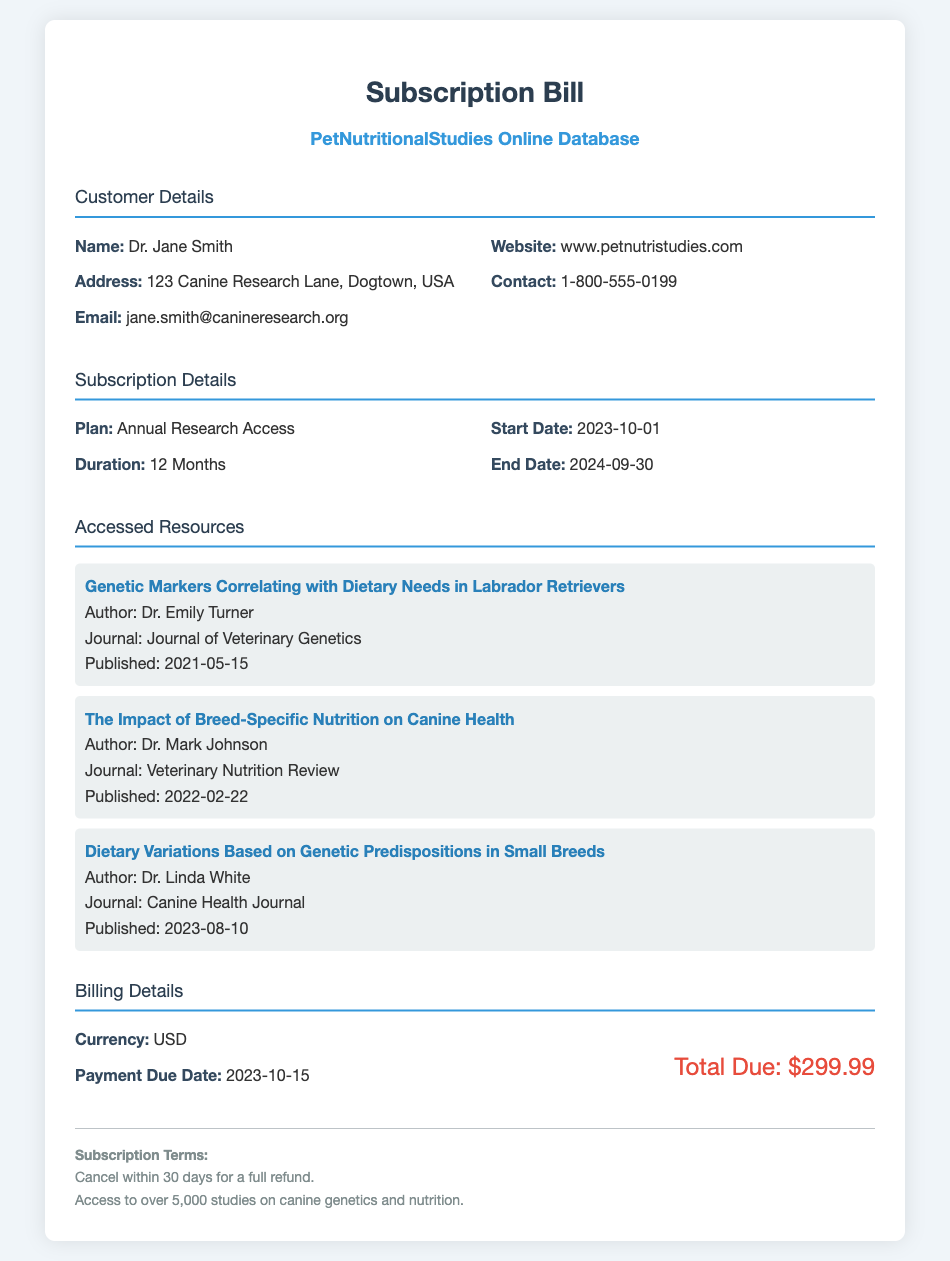what is the name of the customer? The document states the customer's name as Dr. Jane Smith.
Answer: Dr. Jane Smith what is the subscription duration? The document specifies that the subscription duration is 12 months.
Answer: 12 Months when does the subscription start? The document mentions the subscription start date as October 1, 2023.
Answer: 2023-10-01 what is the total amount due? The total amount due, as listed in the billing details, is $299.99.
Answer: $299.99 who authored the resource on genetic markers correlating with dietary needs? The document states that Dr. Emily Turner authored the resource titled "Genetic Markers Correlating with Dietary Needs in Labrador Retrievers."
Answer: Dr. Emily Turner what is the payment due date? The document indicates that the payment due date is October 15, 2023.
Answer: 2023-10-15 how many studies can be accessed with the subscription? The document mentions access to over 5,000 studies on canine genetics and nutrition.
Answer: over 5,000 studies what is the cancellation policy? The cancellation policy states that you can cancel within 30 days for a full refund.
Answer: Cancel within 30 days for a full refund what is the website listed in the document? The document provides the website as www.petnutristudies.com.
Answer: www.petnutristudies.com which journal published the resource on dietary variations in small breeds? The document states that "Dietary Variations Based on Genetic Predispositions in Small Breeds" was published in the Canine Health Journal.
Answer: Canine Health Journal 